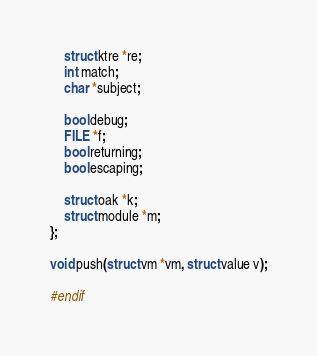<code> <loc_0><loc_0><loc_500><loc_500><_C_>
	struct ktre *re;
	int match;
	char *subject;

	bool debug;
	FILE *f;
	bool returning;
	bool escaping;

	struct oak *k;
	struct module *m;
};

void push(struct vm *vm, struct value v);

#endif
</code> 